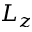Convert formula to latex. <formula><loc_0><loc_0><loc_500><loc_500>L _ { z }</formula> 